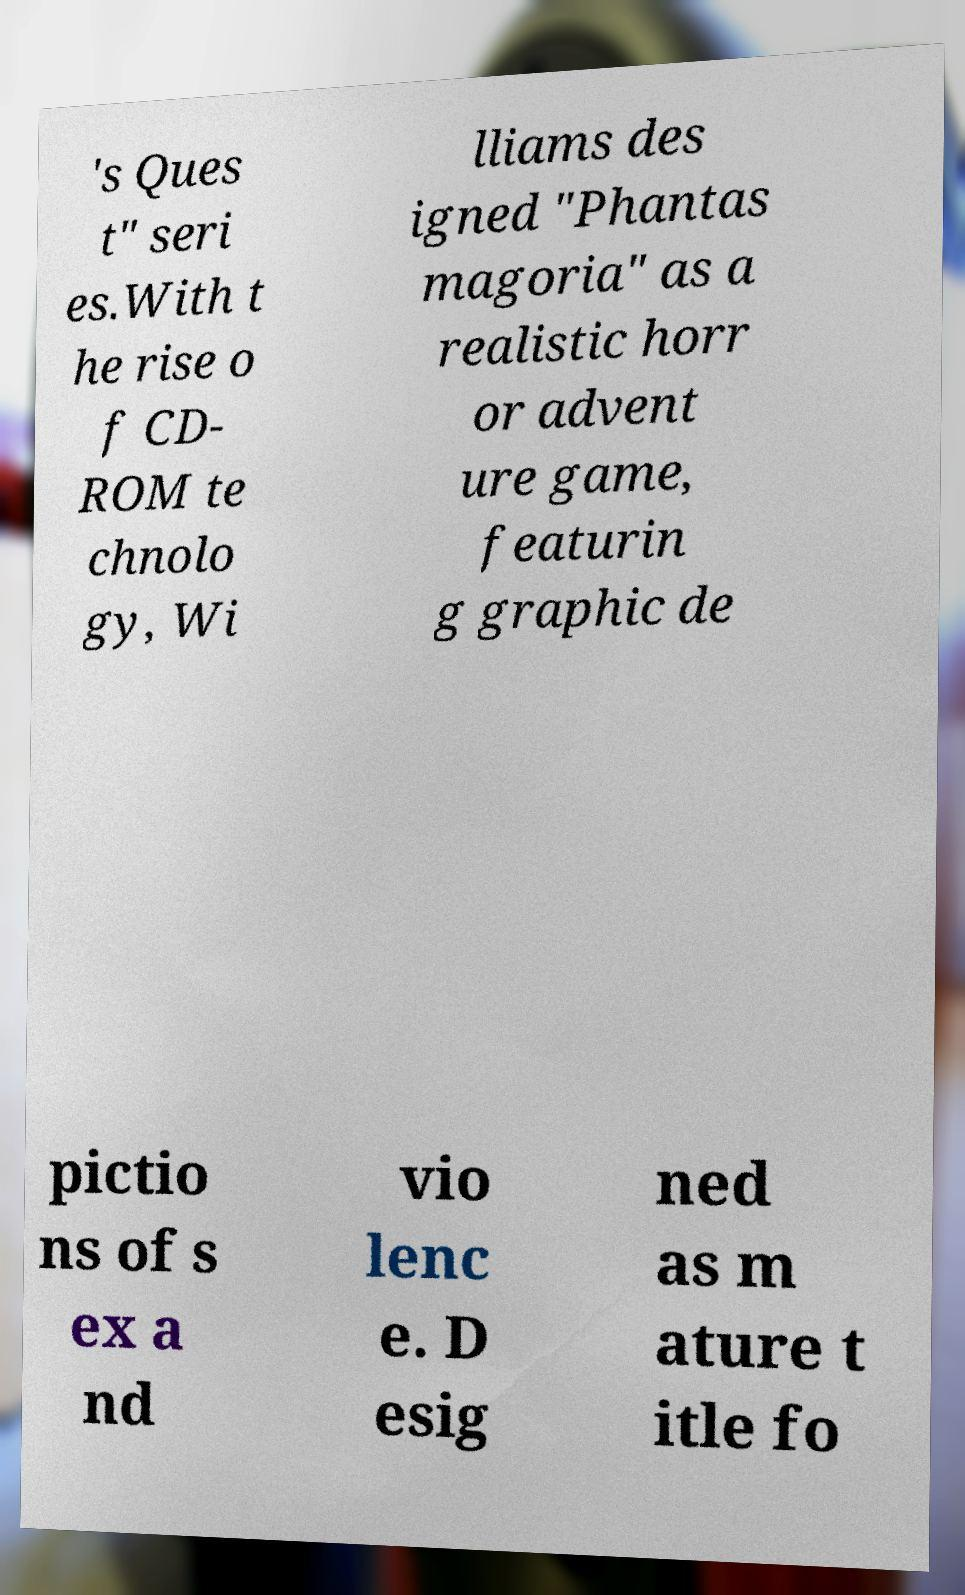Can you read and provide the text displayed in the image?This photo seems to have some interesting text. Can you extract and type it out for me? 's Ques t" seri es.With t he rise o f CD- ROM te chnolo gy, Wi lliams des igned "Phantas magoria" as a realistic horr or advent ure game, featurin g graphic de pictio ns of s ex a nd vio lenc e. D esig ned as m ature t itle fo 